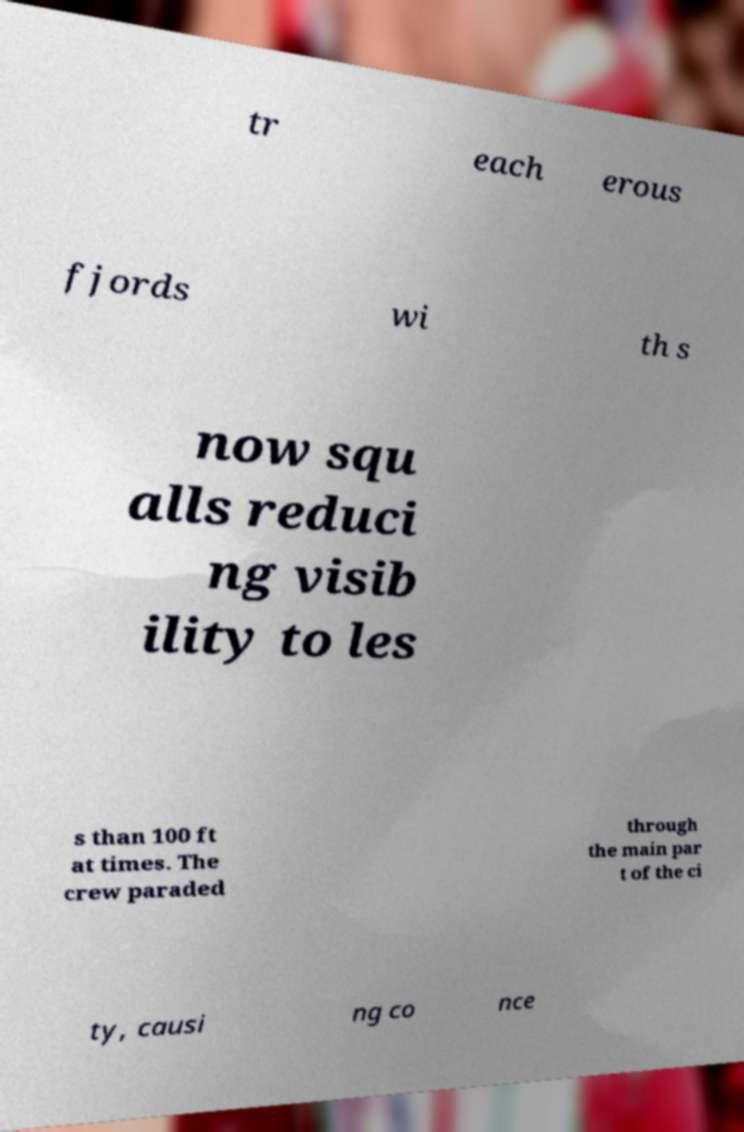What messages or text are displayed in this image? I need them in a readable, typed format. tr each erous fjords wi th s now squ alls reduci ng visib ility to les s than 100 ft at times. The crew paraded through the main par t of the ci ty, causi ng co nce 